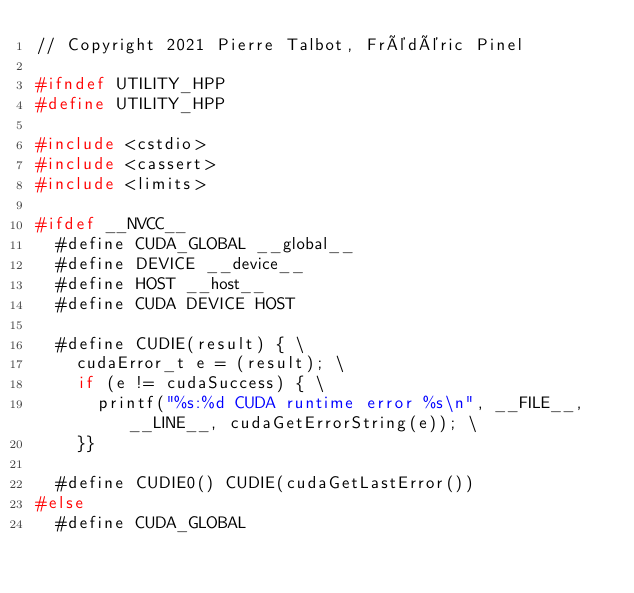<code> <loc_0><loc_0><loc_500><loc_500><_C++_>// Copyright 2021 Pierre Talbot, Frédéric Pinel

#ifndef UTILITY_HPP
#define UTILITY_HPP

#include <cstdio>
#include <cassert>
#include <limits>

#ifdef __NVCC__
  #define CUDA_GLOBAL __global__
  #define DEVICE __device__
  #define HOST __host__
  #define CUDA DEVICE HOST

  #define CUDIE(result) { \
    cudaError_t e = (result); \
    if (e != cudaSuccess) { \
      printf("%s:%d CUDA runtime error %s\n", __FILE__, __LINE__, cudaGetErrorString(e)); \
    }}

  #define CUDIE0() CUDIE(cudaGetLastError())
#else
  #define CUDA_GLOBAL</code> 